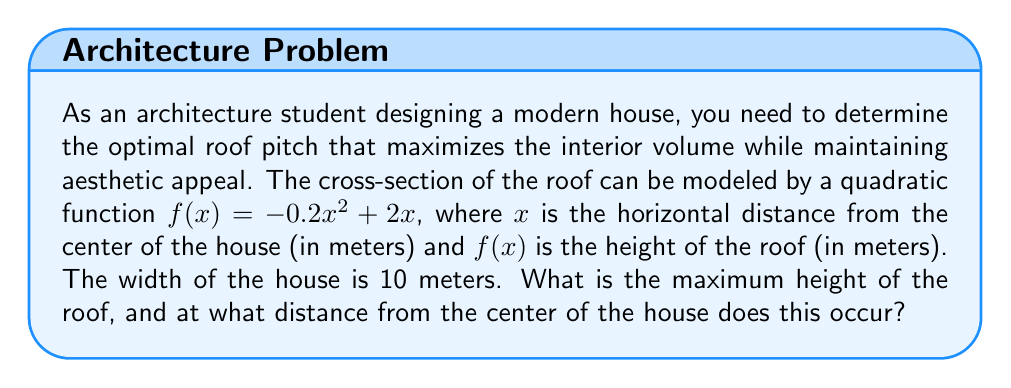Can you solve this math problem? To solve this problem, we need to follow these steps:

1) The quadratic function given is $f(x) = -0.2x^2 + 2x$

2) To find the maximum height of the roof, we need to find the vertex of this parabola. For a quadratic function in the form $f(x) = ax^2 + bx + c$, the x-coordinate of the vertex is given by $x = -\frac{b}{2a}$

3) In our case, $a = -0.2$ and $b = 2$. So:

   $x = -\frac{2}{2(-0.2)} = -\frac{2}{-0.4} = 5$

4) This means the maximum height occurs 5 meters from the center of the house.

5) To find the maximum height, we substitute x = 5 into our original function:

   $f(5) = -0.2(5)^2 + 2(5)$
         $= -0.2(25) + 10$
         $= -5 + 10$
         $= 5$

6) Therefore, the maximum height of the roof is 5 meters.

[asy]
size(200,200);
import graph;

real f(real x) {return -0.2x^2 + 2x;}

draw(graph(f,-5,10));
draw((-5,0)--(10,0),arrow=Arrow(TeXHead));
draw((0,-1)--(0,6),arrow=Arrow(TeXHead));

label("x",(10,0),E);
label("y",(0,6),N);

dot((5,5));
label("(5,5)",(5,5),NE);
[/asy]
Answer: The maximum height of the roof is 5 meters, occurring 5 meters from the center of the house. 